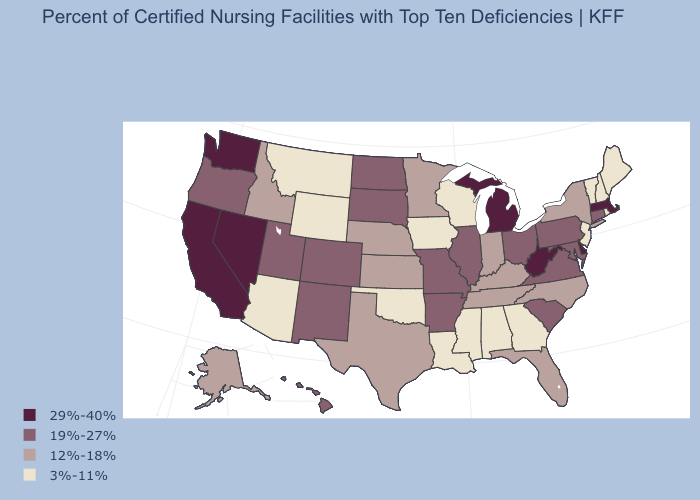What is the highest value in the MidWest ?
Be succinct. 29%-40%. Is the legend a continuous bar?
Be succinct. No. Does Mississippi have a higher value than Connecticut?
Short answer required. No. Does Pennsylvania have the same value as Connecticut?
Short answer required. Yes. Does the first symbol in the legend represent the smallest category?
Be succinct. No. Among the states that border Tennessee , which have the highest value?
Keep it brief. Arkansas, Missouri, Virginia. Which states hav the highest value in the West?
Answer briefly. California, Nevada, Washington. Name the states that have a value in the range 29%-40%?
Quick response, please. California, Delaware, Massachusetts, Michigan, Nevada, Washington, West Virginia. Which states have the lowest value in the West?
Concise answer only. Arizona, Montana, Wyoming. What is the value of Oklahoma?
Write a very short answer. 3%-11%. Among the states that border Rhode Island , which have the highest value?
Be succinct. Massachusetts. Does Nevada have the highest value in the USA?
Concise answer only. Yes. What is the highest value in the USA?
Write a very short answer. 29%-40%. What is the value of Alaska?
Be succinct. 12%-18%. Name the states that have a value in the range 12%-18%?
Give a very brief answer. Alaska, Florida, Idaho, Indiana, Kansas, Kentucky, Minnesota, Nebraska, New York, North Carolina, Tennessee, Texas. 